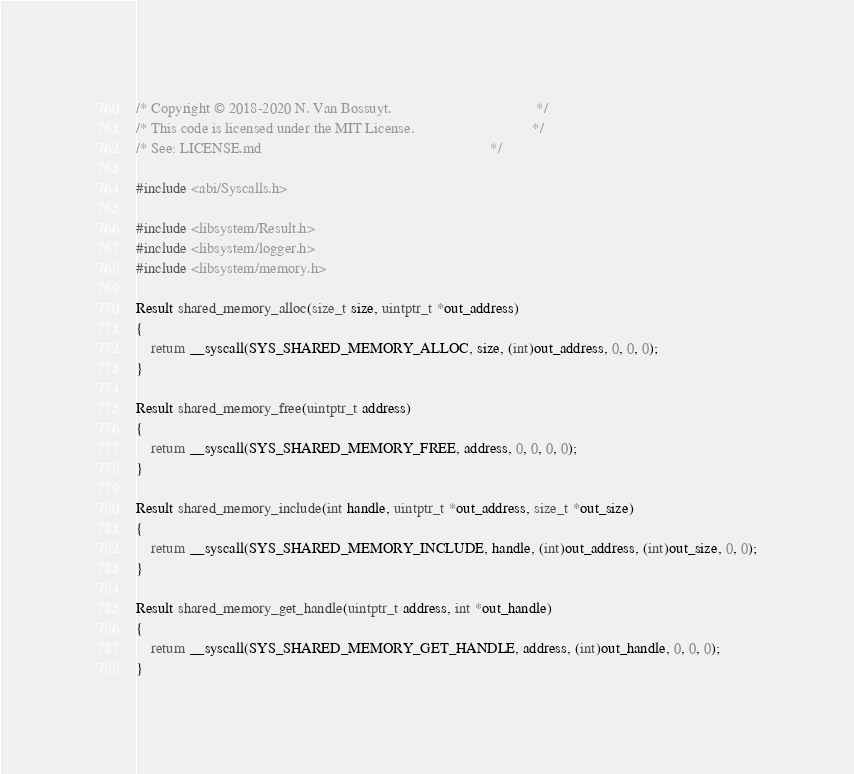Convert code to text. <code><loc_0><loc_0><loc_500><loc_500><_C_>/* Copyright © 2018-2020 N. Van Bossuyt.                                      */
/* This code is licensed under the MIT License.                               */
/* See: LICENSE.md                                                            */

#include <abi/Syscalls.h>

#include <libsystem/Result.h>
#include <libsystem/logger.h>
#include <libsystem/memory.h>

Result shared_memory_alloc(size_t size, uintptr_t *out_address)
{
    return __syscall(SYS_SHARED_MEMORY_ALLOC, size, (int)out_address, 0, 0, 0);
}

Result shared_memory_free(uintptr_t address)
{
    return __syscall(SYS_SHARED_MEMORY_FREE, address, 0, 0, 0, 0);
}

Result shared_memory_include(int handle, uintptr_t *out_address, size_t *out_size)
{
    return __syscall(SYS_SHARED_MEMORY_INCLUDE, handle, (int)out_address, (int)out_size, 0, 0);
}

Result shared_memory_get_handle(uintptr_t address, int *out_handle)
{
    return __syscall(SYS_SHARED_MEMORY_GET_HANDLE, address, (int)out_handle, 0, 0, 0);
}
</code> 